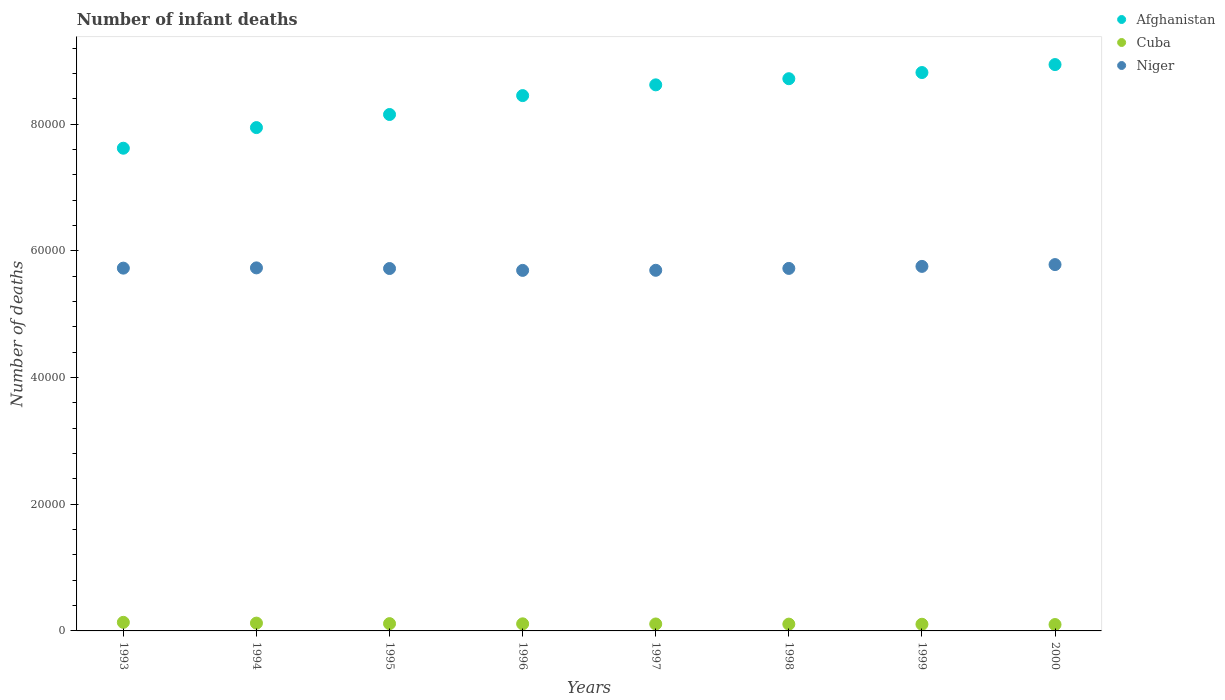Is the number of dotlines equal to the number of legend labels?
Keep it short and to the point. Yes. What is the number of infant deaths in Afghanistan in 1995?
Give a very brief answer. 8.15e+04. Across all years, what is the maximum number of infant deaths in Cuba?
Keep it short and to the point. 1355. Across all years, what is the minimum number of infant deaths in Niger?
Ensure brevity in your answer.  5.69e+04. In which year was the number of infant deaths in Afghanistan maximum?
Provide a short and direct response. 2000. In which year was the number of infant deaths in Niger minimum?
Your answer should be very brief. 1996. What is the total number of infant deaths in Cuba in the graph?
Keep it short and to the point. 9085. What is the difference between the number of infant deaths in Cuba in 1995 and the number of infant deaths in Afghanistan in 1999?
Provide a short and direct response. -8.70e+04. What is the average number of infant deaths in Afghanistan per year?
Make the answer very short. 8.41e+04. In the year 1993, what is the difference between the number of infant deaths in Niger and number of infant deaths in Afghanistan?
Give a very brief answer. -1.89e+04. What is the ratio of the number of infant deaths in Cuba in 1993 to that in 1999?
Keep it short and to the point. 1.29. Is the number of infant deaths in Niger in 1998 less than that in 1999?
Provide a succinct answer. Yes. Is the difference between the number of infant deaths in Niger in 1997 and 1998 greater than the difference between the number of infant deaths in Afghanistan in 1997 and 1998?
Offer a very short reply. Yes. What is the difference between the highest and the second highest number of infant deaths in Niger?
Offer a terse response. 284. What is the difference between the highest and the lowest number of infant deaths in Afghanistan?
Your answer should be compact. 1.32e+04. Is the sum of the number of infant deaths in Niger in 1996 and 2000 greater than the maximum number of infant deaths in Afghanistan across all years?
Make the answer very short. Yes. How many dotlines are there?
Your answer should be compact. 3. How many years are there in the graph?
Ensure brevity in your answer.  8. What is the difference between two consecutive major ticks on the Y-axis?
Offer a very short reply. 2.00e+04. Are the values on the major ticks of Y-axis written in scientific E-notation?
Provide a short and direct response. No. Does the graph contain grids?
Your answer should be very brief. No. Where does the legend appear in the graph?
Your answer should be very brief. Top right. How many legend labels are there?
Provide a succinct answer. 3. What is the title of the graph?
Offer a very short reply. Number of infant deaths. What is the label or title of the Y-axis?
Give a very brief answer. Number of deaths. What is the Number of deaths of Afghanistan in 1993?
Provide a succinct answer. 7.62e+04. What is the Number of deaths of Cuba in 1993?
Offer a very short reply. 1355. What is the Number of deaths in Niger in 1993?
Keep it short and to the point. 5.73e+04. What is the Number of deaths of Afghanistan in 1994?
Your answer should be compact. 7.94e+04. What is the Number of deaths of Cuba in 1994?
Ensure brevity in your answer.  1232. What is the Number of deaths in Niger in 1994?
Offer a very short reply. 5.73e+04. What is the Number of deaths in Afghanistan in 1995?
Give a very brief answer. 8.15e+04. What is the Number of deaths in Cuba in 1995?
Ensure brevity in your answer.  1150. What is the Number of deaths of Niger in 1995?
Provide a succinct answer. 5.72e+04. What is the Number of deaths of Afghanistan in 1996?
Provide a short and direct response. 8.45e+04. What is the Number of deaths of Cuba in 1996?
Your response must be concise. 1119. What is the Number of deaths of Niger in 1996?
Your answer should be very brief. 5.69e+04. What is the Number of deaths in Afghanistan in 1997?
Provide a short and direct response. 8.62e+04. What is the Number of deaths of Cuba in 1997?
Your response must be concise. 1097. What is the Number of deaths of Niger in 1997?
Provide a short and direct response. 5.69e+04. What is the Number of deaths in Afghanistan in 1998?
Provide a short and direct response. 8.72e+04. What is the Number of deaths of Cuba in 1998?
Offer a terse response. 1073. What is the Number of deaths in Niger in 1998?
Your answer should be very brief. 5.72e+04. What is the Number of deaths in Afghanistan in 1999?
Give a very brief answer. 8.81e+04. What is the Number of deaths of Cuba in 1999?
Your response must be concise. 1052. What is the Number of deaths of Niger in 1999?
Your response must be concise. 5.75e+04. What is the Number of deaths of Afghanistan in 2000?
Give a very brief answer. 8.94e+04. What is the Number of deaths of Cuba in 2000?
Provide a short and direct response. 1007. What is the Number of deaths of Niger in 2000?
Provide a short and direct response. 5.78e+04. Across all years, what is the maximum Number of deaths in Afghanistan?
Provide a short and direct response. 8.94e+04. Across all years, what is the maximum Number of deaths of Cuba?
Ensure brevity in your answer.  1355. Across all years, what is the maximum Number of deaths in Niger?
Your answer should be very brief. 5.78e+04. Across all years, what is the minimum Number of deaths in Afghanistan?
Provide a succinct answer. 7.62e+04. Across all years, what is the minimum Number of deaths in Cuba?
Offer a very short reply. 1007. Across all years, what is the minimum Number of deaths of Niger?
Your answer should be compact. 5.69e+04. What is the total Number of deaths of Afghanistan in the graph?
Give a very brief answer. 6.73e+05. What is the total Number of deaths of Cuba in the graph?
Offer a terse response. 9085. What is the total Number of deaths of Niger in the graph?
Offer a terse response. 4.58e+05. What is the difference between the Number of deaths in Afghanistan in 1993 and that in 1994?
Your answer should be very brief. -3256. What is the difference between the Number of deaths of Cuba in 1993 and that in 1994?
Provide a short and direct response. 123. What is the difference between the Number of deaths in Niger in 1993 and that in 1994?
Provide a succinct answer. -40. What is the difference between the Number of deaths of Afghanistan in 1993 and that in 1995?
Your response must be concise. -5323. What is the difference between the Number of deaths in Cuba in 1993 and that in 1995?
Ensure brevity in your answer.  205. What is the difference between the Number of deaths of Afghanistan in 1993 and that in 1996?
Your answer should be compact. -8305. What is the difference between the Number of deaths in Cuba in 1993 and that in 1996?
Your response must be concise. 236. What is the difference between the Number of deaths of Niger in 1993 and that in 1996?
Give a very brief answer. 355. What is the difference between the Number of deaths in Afghanistan in 1993 and that in 1997?
Offer a very short reply. -1.00e+04. What is the difference between the Number of deaths in Cuba in 1993 and that in 1997?
Give a very brief answer. 258. What is the difference between the Number of deaths in Niger in 1993 and that in 1997?
Give a very brief answer. 340. What is the difference between the Number of deaths of Afghanistan in 1993 and that in 1998?
Make the answer very short. -1.10e+04. What is the difference between the Number of deaths in Cuba in 1993 and that in 1998?
Provide a short and direct response. 282. What is the difference between the Number of deaths of Niger in 1993 and that in 1998?
Your answer should be very brief. 44. What is the difference between the Number of deaths in Afghanistan in 1993 and that in 1999?
Offer a very short reply. -1.19e+04. What is the difference between the Number of deaths of Cuba in 1993 and that in 1999?
Offer a very short reply. 303. What is the difference between the Number of deaths of Niger in 1993 and that in 1999?
Keep it short and to the point. -276. What is the difference between the Number of deaths in Afghanistan in 1993 and that in 2000?
Keep it short and to the point. -1.32e+04. What is the difference between the Number of deaths in Cuba in 1993 and that in 2000?
Keep it short and to the point. 348. What is the difference between the Number of deaths in Niger in 1993 and that in 2000?
Offer a very short reply. -560. What is the difference between the Number of deaths in Afghanistan in 1994 and that in 1995?
Give a very brief answer. -2067. What is the difference between the Number of deaths of Cuba in 1994 and that in 1995?
Your response must be concise. 82. What is the difference between the Number of deaths in Niger in 1994 and that in 1995?
Your answer should be compact. 101. What is the difference between the Number of deaths in Afghanistan in 1994 and that in 1996?
Your response must be concise. -5049. What is the difference between the Number of deaths in Cuba in 1994 and that in 1996?
Keep it short and to the point. 113. What is the difference between the Number of deaths in Niger in 1994 and that in 1996?
Ensure brevity in your answer.  395. What is the difference between the Number of deaths in Afghanistan in 1994 and that in 1997?
Provide a succinct answer. -6747. What is the difference between the Number of deaths of Cuba in 1994 and that in 1997?
Give a very brief answer. 135. What is the difference between the Number of deaths of Niger in 1994 and that in 1997?
Keep it short and to the point. 380. What is the difference between the Number of deaths in Afghanistan in 1994 and that in 1998?
Give a very brief answer. -7716. What is the difference between the Number of deaths of Cuba in 1994 and that in 1998?
Provide a succinct answer. 159. What is the difference between the Number of deaths of Afghanistan in 1994 and that in 1999?
Keep it short and to the point. -8690. What is the difference between the Number of deaths in Cuba in 1994 and that in 1999?
Provide a short and direct response. 180. What is the difference between the Number of deaths of Niger in 1994 and that in 1999?
Your answer should be compact. -236. What is the difference between the Number of deaths in Afghanistan in 1994 and that in 2000?
Your answer should be very brief. -9947. What is the difference between the Number of deaths in Cuba in 1994 and that in 2000?
Ensure brevity in your answer.  225. What is the difference between the Number of deaths of Niger in 1994 and that in 2000?
Offer a very short reply. -520. What is the difference between the Number of deaths in Afghanistan in 1995 and that in 1996?
Ensure brevity in your answer.  -2982. What is the difference between the Number of deaths in Cuba in 1995 and that in 1996?
Provide a succinct answer. 31. What is the difference between the Number of deaths of Niger in 1995 and that in 1996?
Provide a succinct answer. 294. What is the difference between the Number of deaths in Afghanistan in 1995 and that in 1997?
Your answer should be compact. -4680. What is the difference between the Number of deaths in Niger in 1995 and that in 1997?
Your response must be concise. 279. What is the difference between the Number of deaths in Afghanistan in 1995 and that in 1998?
Your response must be concise. -5649. What is the difference between the Number of deaths in Afghanistan in 1995 and that in 1999?
Provide a short and direct response. -6623. What is the difference between the Number of deaths in Cuba in 1995 and that in 1999?
Offer a terse response. 98. What is the difference between the Number of deaths of Niger in 1995 and that in 1999?
Make the answer very short. -337. What is the difference between the Number of deaths of Afghanistan in 1995 and that in 2000?
Offer a very short reply. -7880. What is the difference between the Number of deaths in Cuba in 1995 and that in 2000?
Offer a very short reply. 143. What is the difference between the Number of deaths of Niger in 1995 and that in 2000?
Offer a terse response. -621. What is the difference between the Number of deaths in Afghanistan in 1996 and that in 1997?
Give a very brief answer. -1698. What is the difference between the Number of deaths in Niger in 1996 and that in 1997?
Your response must be concise. -15. What is the difference between the Number of deaths of Afghanistan in 1996 and that in 1998?
Keep it short and to the point. -2667. What is the difference between the Number of deaths in Niger in 1996 and that in 1998?
Your answer should be compact. -311. What is the difference between the Number of deaths in Afghanistan in 1996 and that in 1999?
Provide a short and direct response. -3641. What is the difference between the Number of deaths of Niger in 1996 and that in 1999?
Make the answer very short. -631. What is the difference between the Number of deaths in Afghanistan in 1996 and that in 2000?
Ensure brevity in your answer.  -4898. What is the difference between the Number of deaths in Cuba in 1996 and that in 2000?
Make the answer very short. 112. What is the difference between the Number of deaths of Niger in 1996 and that in 2000?
Your answer should be very brief. -915. What is the difference between the Number of deaths of Afghanistan in 1997 and that in 1998?
Provide a short and direct response. -969. What is the difference between the Number of deaths in Niger in 1997 and that in 1998?
Provide a succinct answer. -296. What is the difference between the Number of deaths in Afghanistan in 1997 and that in 1999?
Keep it short and to the point. -1943. What is the difference between the Number of deaths of Cuba in 1997 and that in 1999?
Ensure brevity in your answer.  45. What is the difference between the Number of deaths in Niger in 1997 and that in 1999?
Provide a short and direct response. -616. What is the difference between the Number of deaths in Afghanistan in 1997 and that in 2000?
Your answer should be compact. -3200. What is the difference between the Number of deaths in Niger in 1997 and that in 2000?
Your response must be concise. -900. What is the difference between the Number of deaths of Afghanistan in 1998 and that in 1999?
Give a very brief answer. -974. What is the difference between the Number of deaths of Cuba in 1998 and that in 1999?
Make the answer very short. 21. What is the difference between the Number of deaths in Niger in 1998 and that in 1999?
Give a very brief answer. -320. What is the difference between the Number of deaths in Afghanistan in 1998 and that in 2000?
Your answer should be compact. -2231. What is the difference between the Number of deaths of Cuba in 1998 and that in 2000?
Your answer should be compact. 66. What is the difference between the Number of deaths in Niger in 1998 and that in 2000?
Keep it short and to the point. -604. What is the difference between the Number of deaths of Afghanistan in 1999 and that in 2000?
Provide a succinct answer. -1257. What is the difference between the Number of deaths in Cuba in 1999 and that in 2000?
Keep it short and to the point. 45. What is the difference between the Number of deaths in Niger in 1999 and that in 2000?
Make the answer very short. -284. What is the difference between the Number of deaths in Afghanistan in 1993 and the Number of deaths in Cuba in 1994?
Keep it short and to the point. 7.50e+04. What is the difference between the Number of deaths of Afghanistan in 1993 and the Number of deaths of Niger in 1994?
Your answer should be very brief. 1.89e+04. What is the difference between the Number of deaths of Cuba in 1993 and the Number of deaths of Niger in 1994?
Provide a short and direct response. -5.59e+04. What is the difference between the Number of deaths in Afghanistan in 1993 and the Number of deaths in Cuba in 1995?
Offer a terse response. 7.50e+04. What is the difference between the Number of deaths in Afghanistan in 1993 and the Number of deaths in Niger in 1995?
Offer a very short reply. 1.90e+04. What is the difference between the Number of deaths of Cuba in 1993 and the Number of deaths of Niger in 1995?
Your response must be concise. -5.58e+04. What is the difference between the Number of deaths in Afghanistan in 1993 and the Number of deaths in Cuba in 1996?
Your response must be concise. 7.51e+04. What is the difference between the Number of deaths in Afghanistan in 1993 and the Number of deaths in Niger in 1996?
Offer a very short reply. 1.93e+04. What is the difference between the Number of deaths of Cuba in 1993 and the Number of deaths of Niger in 1996?
Offer a terse response. -5.56e+04. What is the difference between the Number of deaths in Afghanistan in 1993 and the Number of deaths in Cuba in 1997?
Offer a terse response. 7.51e+04. What is the difference between the Number of deaths of Afghanistan in 1993 and the Number of deaths of Niger in 1997?
Your answer should be compact. 1.93e+04. What is the difference between the Number of deaths in Cuba in 1993 and the Number of deaths in Niger in 1997?
Offer a very short reply. -5.56e+04. What is the difference between the Number of deaths in Afghanistan in 1993 and the Number of deaths in Cuba in 1998?
Provide a succinct answer. 7.51e+04. What is the difference between the Number of deaths in Afghanistan in 1993 and the Number of deaths in Niger in 1998?
Keep it short and to the point. 1.90e+04. What is the difference between the Number of deaths in Cuba in 1993 and the Number of deaths in Niger in 1998?
Offer a very short reply. -5.59e+04. What is the difference between the Number of deaths of Afghanistan in 1993 and the Number of deaths of Cuba in 1999?
Give a very brief answer. 7.51e+04. What is the difference between the Number of deaths in Afghanistan in 1993 and the Number of deaths in Niger in 1999?
Your answer should be compact. 1.87e+04. What is the difference between the Number of deaths of Cuba in 1993 and the Number of deaths of Niger in 1999?
Offer a terse response. -5.62e+04. What is the difference between the Number of deaths of Afghanistan in 1993 and the Number of deaths of Cuba in 2000?
Offer a terse response. 7.52e+04. What is the difference between the Number of deaths of Afghanistan in 1993 and the Number of deaths of Niger in 2000?
Your response must be concise. 1.84e+04. What is the difference between the Number of deaths in Cuba in 1993 and the Number of deaths in Niger in 2000?
Make the answer very short. -5.65e+04. What is the difference between the Number of deaths in Afghanistan in 1994 and the Number of deaths in Cuba in 1995?
Provide a short and direct response. 7.83e+04. What is the difference between the Number of deaths of Afghanistan in 1994 and the Number of deaths of Niger in 1995?
Make the answer very short. 2.22e+04. What is the difference between the Number of deaths of Cuba in 1994 and the Number of deaths of Niger in 1995?
Make the answer very short. -5.60e+04. What is the difference between the Number of deaths in Afghanistan in 1994 and the Number of deaths in Cuba in 1996?
Keep it short and to the point. 7.83e+04. What is the difference between the Number of deaths in Afghanistan in 1994 and the Number of deaths in Niger in 1996?
Provide a succinct answer. 2.25e+04. What is the difference between the Number of deaths of Cuba in 1994 and the Number of deaths of Niger in 1996?
Ensure brevity in your answer.  -5.57e+04. What is the difference between the Number of deaths in Afghanistan in 1994 and the Number of deaths in Cuba in 1997?
Your answer should be very brief. 7.83e+04. What is the difference between the Number of deaths of Afghanistan in 1994 and the Number of deaths of Niger in 1997?
Provide a short and direct response. 2.25e+04. What is the difference between the Number of deaths in Cuba in 1994 and the Number of deaths in Niger in 1997?
Offer a very short reply. -5.57e+04. What is the difference between the Number of deaths in Afghanistan in 1994 and the Number of deaths in Cuba in 1998?
Make the answer very short. 7.84e+04. What is the difference between the Number of deaths in Afghanistan in 1994 and the Number of deaths in Niger in 1998?
Your answer should be compact. 2.22e+04. What is the difference between the Number of deaths of Cuba in 1994 and the Number of deaths of Niger in 1998?
Your answer should be very brief. -5.60e+04. What is the difference between the Number of deaths in Afghanistan in 1994 and the Number of deaths in Cuba in 1999?
Provide a short and direct response. 7.84e+04. What is the difference between the Number of deaths of Afghanistan in 1994 and the Number of deaths of Niger in 1999?
Your answer should be very brief. 2.19e+04. What is the difference between the Number of deaths of Cuba in 1994 and the Number of deaths of Niger in 1999?
Provide a succinct answer. -5.63e+04. What is the difference between the Number of deaths in Afghanistan in 1994 and the Number of deaths in Cuba in 2000?
Make the answer very short. 7.84e+04. What is the difference between the Number of deaths in Afghanistan in 1994 and the Number of deaths in Niger in 2000?
Provide a short and direct response. 2.16e+04. What is the difference between the Number of deaths of Cuba in 1994 and the Number of deaths of Niger in 2000?
Your answer should be compact. -5.66e+04. What is the difference between the Number of deaths in Afghanistan in 1995 and the Number of deaths in Cuba in 1996?
Ensure brevity in your answer.  8.04e+04. What is the difference between the Number of deaths in Afghanistan in 1995 and the Number of deaths in Niger in 1996?
Provide a short and direct response. 2.46e+04. What is the difference between the Number of deaths in Cuba in 1995 and the Number of deaths in Niger in 1996?
Provide a succinct answer. -5.58e+04. What is the difference between the Number of deaths in Afghanistan in 1995 and the Number of deaths in Cuba in 1997?
Provide a short and direct response. 8.04e+04. What is the difference between the Number of deaths of Afghanistan in 1995 and the Number of deaths of Niger in 1997?
Provide a short and direct response. 2.46e+04. What is the difference between the Number of deaths in Cuba in 1995 and the Number of deaths in Niger in 1997?
Make the answer very short. -5.58e+04. What is the difference between the Number of deaths in Afghanistan in 1995 and the Number of deaths in Cuba in 1998?
Your response must be concise. 8.04e+04. What is the difference between the Number of deaths in Afghanistan in 1995 and the Number of deaths in Niger in 1998?
Your answer should be very brief. 2.43e+04. What is the difference between the Number of deaths in Cuba in 1995 and the Number of deaths in Niger in 1998?
Provide a short and direct response. -5.61e+04. What is the difference between the Number of deaths in Afghanistan in 1995 and the Number of deaths in Cuba in 1999?
Provide a short and direct response. 8.05e+04. What is the difference between the Number of deaths of Afghanistan in 1995 and the Number of deaths of Niger in 1999?
Your answer should be compact. 2.40e+04. What is the difference between the Number of deaths of Cuba in 1995 and the Number of deaths of Niger in 1999?
Provide a succinct answer. -5.64e+04. What is the difference between the Number of deaths of Afghanistan in 1995 and the Number of deaths of Cuba in 2000?
Your answer should be very brief. 8.05e+04. What is the difference between the Number of deaths of Afghanistan in 1995 and the Number of deaths of Niger in 2000?
Offer a terse response. 2.37e+04. What is the difference between the Number of deaths of Cuba in 1995 and the Number of deaths of Niger in 2000?
Provide a succinct answer. -5.67e+04. What is the difference between the Number of deaths of Afghanistan in 1996 and the Number of deaths of Cuba in 1997?
Offer a terse response. 8.34e+04. What is the difference between the Number of deaths in Afghanistan in 1996 and the Number of deaths in Niger in 1997?
Offer a very short reply. 2.76e+04. What is the difference between the Number of deaths in Cuba in 1996 and the Number of deaths in Niger in 1997?
Your answer should be very brief. -5.58e+04. What is the difference between the Number of deaths of Afghanistan in 1996 and the Number of deaths of Cuba in 1998?
Keep it short and to the point. 8.34e+04. What is the difference between the Number of deaths of Afghanistan in 1996 and the Number of deaths of Niger in 1998?
Offer a terse response. 2.73e+04. What is the difference between the Number of deaths of Cuba in 1996 and the Number of deaths of Niger in 1998?
Give a very brief answer. -5.61e+04. What is the difference between the Number of deaths of Afghanistan in 1996 and the Number of deaths of Cuba in 1999?
Make the answer very short. 8.34e+04. What is the difference between the Number of deaths in Afghanistan in 1996 and the Number of deaths in Niger in 1999?
Make the answer very short. 2.70e+04. What is the difference between the Number of deaths in Cuba in 1996 and the Number of deaths in Niger in 1999?
Give a very brief answer. -5.64e+04. What is the difference between the Number of deaths in Afghanistan in 1996 and the Number of deaths in Cuba in 2000?
Offer a terse response. 8.35e+04. What is the difference between the Number of deaths in Afghanistan in 1996 and the Number of deaths in Niger in 2000?
Ensure brevity in your answer.  2.67e+04. What is the difference between the Number of deaths of Cuba in 1996 and the Number of deaths of Niger in 2000?
Your answer should be compact. -5.67e+04. What is the difference between the Number of deaths in Afghanistan in 1997 and the Number of deaths in Cuba in 1998?
Offer a terse response. 8.51e+04. What is the difference between the Number of deaths in Afghanistan in 1997 and the Number of deaths in Niger in 1998?
Ensure brevity in your answer.  2.90e+04. What is the difference between the Number of deaths of Cuba in 1997 and the Number of deaths of Niger in 1998?
Make the answer very short. -5.61e+04. What is the difference between the Number of deaths in Afghanistan in 1997 and the Number of deaths in Cuba in 1999?
Offer a very short reply. 8.51e+04. What is the difference between the Number of deaths of Afghanistan in 1997 and the Number of deaths of Niger in 1999?
Provide a succinct answer. 2.87e+04. What is the difference between the Number of deaths of Cuba in 1997 and the Number of deaths of Niger in 1999?
Your response must be concise. -5.64e+04. What is the difference between the Number of deaths of Afghanistan in 1997 and the Number of deaths of Cuba in 2000?
Give a very brief answer. 8.52e+04. What is the difference between the Number of deaths of Afghanistan in 1997 and the Number of deaths of Niger in 2000?
Your response must be concise. 2.84e+04. What is the difference between the Number of deaths in Cuba in 1997 and the Number of deaths in Niger in 2000?
Give a very brief answer. -5.67e+04. What is the difference between the Number of deaths of Afghanistan in 1998 and the Number of deaths of Cuba in 1999?
Ensure brevity in your answer.  8.61e+04. What is the difference between the Number of deaths of Afghanistan in 1998 and the Number of deaths of Niger in 1999?
Provide a succinct answer. 2.96e+04. What is the difference between the Number of deaths in Cuba in 1998 and the Number of deaths in Niger in 1999?
Ensure brevity in your answer.  -5.65e+04. What is the difference between the Number of deaths in Afghanistan in 1998 and the Number of deaths in Cuba in 2000?
Your response must be concise. 8.62e+04. What is the difference between the Number of deaths in Afghanistan in 1998 and the Number of deaths in Niger in 2000?
Offer a very short reply. 2.93e+04. What is the difference between the Number of deaths in Cuba in 1998 and the Number of deaths in Niger in 2000?
Provide a short and direct response. -5.67e+04. What is the difference between the Number of deaths of Afghanistan in 1999 and the Number of deaths of Cuba in 2000?
Provide a short and direct response. 8.71e+04. What is the difference between the Number of deaths of Afghanistan in 1999 and the Number of deaths of Niger in 2000?
Your response must be concise. 3.03e+04. What is the difference between the Number of deaths of Cuba in 1999 and the Number of deaths of Niger in 2000?
Ensure brevity in your answer.  -5.68e+04. What is the average Number of deaths in Afghanistan per year?
Give a very brief answer. 8.41e+04. What is the average Number of deaths in Cuba per year?
Provide a succinct answer. 1135.62. What is the average Number of deaths of Niger per year?
Offer a terse response. 5.73e+04. In the year 1993, what is the difference between the Number of deaths in Afghanistan and Number of deaths in Cuba?
Your response must be concise. 7.48e+04. In the year 1993, what is the difference between the Number of deaths of Afghanistan and Number of deaths of Niger?
Offer a very short reply. 1.89e+04. In the year 1993, what is the difference between the Number of deaths of Cuba and Number of deaths of Niger?
Offer a terse response. -5.59e+04. In the year 1994, what is the difference between the Number of deaths in Afghanistan and Number of deaths in Cuba?
Make the answer very short. 7.82e+04. In the year 1994, what is the difference between the Number of deaths of Afghanistan and Number of deaths of Niger?
Ensure brevity in your answer.  2.21e+04. In the year 1994, what is the difference between the Number of deaths of Cuba and Number of deaths of Niger?
Ensure brevity in your answer.  -5.61e+04. In the year 1995, what is the difference between the Number of deaths in Afghanistan and Number of deaths in Cuba?
Your answer should be compact. 8.04e+04. In the year 1995, what is the difference between the Number of deaths in Afghanistan and Number of deaths in Niger?
Make the answer very short. 2.43e+04. In the year 1995, what is the difference between the Number of deaths of Cuba and Number of deaths of Niger?
Keep it short and to the point. -5.61e+04. In the year 1996, what is the difference between the Number of deaths in Afghanistan and Number of deaths in Cuba?
Your answer should be very brief. 8.34e+04. In the year 1996, what is the difference between the Number of deaths in Afghanistan and Number of deaths in Niger?
Keep it short and to the point. 2.76e+04. In the year 1996, what is the difference between the Number of deaths in Cuba and Number of deaths in Niger?
Ensure brevity in your answer.  -5.58e+04. In the year 1997, what is the difference between the Number of deaths in Afghanistan and Number of deaths in Cuba?
Ensure brevity in your answer.  8.51e+04. In the year 1997, what is the difference between the Number of deaths of Afghanistan and Number of deaths of Niger?
Your response must be concise. 2.93e+04. In the year 1997, what is the difference between the Number of deaths in Cuba and Number of deaths in Niger?
Ensure brevity in your answer.  -5.58e+04. In the year 1998, what is the difference between the Number of deaths of Afghanistan and Number of deaths of Cuba?
Ensure brevity in your answer.  8.61e+04. In the year 1998, what is the difference between the Number of deaths in Afghanistan and Number of deaths in Niger?
Give a very brief answer. 2.99e+04. In the year 1998, what is the difference between the Number of deaths in Cuba and Number of deaths in Niger?
Provide a succinct answer. -5.61e+04. In the year 1999, what is the difference between the Number of deaths of Afghanistan and Number of deaths of Cuba?
Your answer should be very brief. 8.71e+04. In the year 1999, what is the difference between the Number of deaths of Afghanistan and Number of deaths of Niger?
Your answer should be compact. 3.06e+04. In the year 1999, what is the difference between the Number of deaths in Cuba and Number of deaths in Niger?
Your response must be concise. -5.65e+04. In the year 2000, what is the difference between the Number of deaths of Afghanistan and Number of deaths of Cuba?
Give a very brief answer. 8.84e+04. In the year 2000, what is the difference between the Number of deaths of Afghanistan and Number of deaths of Niger?
Offer a terse response. 3.16e+04. In the year 2000, what is the difference between the Number of deaths in Cuba and Number of deaths in Niger?
Ensure brevity in your answer.  -5.68e+04. What is the ratio of the Number of deaths of Afghanistan in 1993 to that in 1994?
Provide a short and direct response. 0.96. What is the ratio of the Number of deaths of Cuba in 1993 to that in 1994?
Offer a very short reply. 1.1. What is the ratio of the Number of deaths in Niger in 1993 to that in 1994?
Provide a short and direct response. 1. What is the ratio of the Number of deaths of Afghanistan in 1993 to that in 1995?
Provide a short and direct response. 0.93. What is the ratio of the Number of deaths of Cuba in 1993 to that in 1995?
Make the answer very short. 1.18. What is the ratio of the Number of deaths in Niger in 1993 to that in 1995?
Offer a very short reply. 1. What is the ratio of the Number of deaths in Afghanistan in 1993 to that in 1996?
Keep it short and to the point. 0.9. What is the ratio of the Number of deaths of Cuba in 1993 to that in 1996?
Offer a terse response. 1.21. What is the ratio of the Number of deaths of Afghanistan in 1993 to that in 1997?
Provide a succinct answer. 0.88. What is the ratio of the Number of deaths in Cuba in 1993 to that in 1997?
Make the answer very short. 1.24. What is the ratio of the Number of deaths in Niger in 1993 to that in 1997?
Keep it short and to the point. 1.01. What is the ratio of the Number of deaths in Afghanistan in 1993 to that in 1998?
Offer a very short reply. 0.87. What is the ratio of the Number of deaths of Cuba in 1993 to that in 1998?
Ensure brevity in your answer.  1.26. What is the ratio of the Number of deaths in Niger in 1993 to that in 1998?
Your answer should be very brief. 1. What is the ratio of the Number of deaths in Afghanistan in 1993 to that in 1999?
Your response must be concise. 0.86. What is the ratio of the Number of deaths in Cuba in 1993 to that in 1999?
Provide a short and direct response. 1.29. What is the ratio of the Number of deaths of Niger in 1993 to that in 1999?
Give a very brief answer. 1. What is the ratio of the Number of deaths of Afghanistan in 1993 to that in 2000?
Give a very brief answer. 0.85. What is the ratio of the Number of deaths in Cuba in 1993 to that in 2000?
Make the answer very short. 1.35. What is the ratio of the Number of deaths of Niger in 1993 to that in 2000?
Offer a terse response. 0.99. What is the ratio of the Number of deaths of Afghanistan in 1994 to that in 1995?
Make the answer very short. 0.97. What is the ratio of the Number of deaths in Cuba in 1994 to that in 1995?
Ensure brevity in your answer.  1.07. What is the ratio of the Number of deaths in Niger in 1994 to that in 1995?
Your answer should be very brief. 1. What is the ratio of the Number of deaths in Afghanistan in 1994 to that in 1996?
Offer a terse response. 0.94. What is the ratio of the Number of deaths of Cuba in 1994 to that in 1996?
Provide a short and direct response. 1.1. What is the ratio of the Number of deaths of Afghanistan in 1994 to that in 1997?
Ensure brevity in your answer.  0.92. What is the ratio of the Number of deaths of Cuba in 1994 to that in 1997?
Your answer should be compact. 1.12. What is the ratio of the Number of deaths in Afghanistan in 1994 to that in 1998?
Give a very brief answer. 0.91. What is the ratio of the Number of deaths in Cuba in 1994 to that in 1998?
Your answer should be compact. 1.15. What is the ratio of the Number of deaths in Niger in 1994 to that in 1998?
Provide a succinct answer. 1. What is the ratio of the Number of deaths in Afghanistan in 1994 to that in 1999?
Provide a succinct answer. 0.9. What is the ratio of the Number of deaths of Cuba in 1994 to that in 1999?
Keep it short and to the point. 1.17. What is the ratio of the Number of deaths in Niger in 1994 to that in 1999?
Offer a very short reply. 1. What is the ratio of the Number of deaths of Afghanistan in 1994 to that in 2000?
Make the answer very short. 0.89. What is the ratio of the Number of deaths in Cuba in 1994 to that in 2000?
Your response must be concise. 1.22. What is the ratio of the Number of deaths of Afghanistan in 1995 to that in 1996?
Make the answer very short. 0.96. What is the ratio of the Number of deaths in Cuba in 1995 to that in 1996?
Your answer should be very brief. 1.03. What is the ratio of the Number of deaths of Niger in 1995 to that in 1996?
Ensure brevity in your answer.  1.01. What is the ratio of the Number of deaths in Afghanistan in 1995 to that in 1997?
Keep it short and to the point. 0.95. What is the ratio of the Number of deaths of Cuba in 1995 to that in 1997?
Your answer should be very brief. 1.05. What is the ratio of the Number of deaths of Niger in 1995 to that in 1997?
Ensure brevity in your answer.  1. What is the ratio of the Number of deaths in Afghanistan in 1995 to that in 1998?
Offer a very short reply. 0.94. What is the ratio of the Number of deaths in Cuba in 1995 to that in 1998?
Offer a terse response. 1.07. What is the ratio of the Number of deaths of Niger in 1995 to that in 1998?
Offer a very short reply. 1. What is the ratio of the Number of deaths in Afghanistan in 1995 to that in 1999?
Make the answer very short. 0.92. What is the ratio of the Number of deaths in Cuba in 1995 to that in 1999?
Ensure brevity in your answer.  1.09. What is the ratio of the Number of deaths of Afghanistan in 1995 to that in 2000?
Keep it short and to the point. 0.91. What is the ratio of the Number of deaths in Cuba in 1995 to that in 2000?
Offer a terse response. 1.14. What is the ratio of the Number of deaths of Niger in 1995 to that in 2000?
Give a very brief answer. 0.99. What is the ratio of the Number of deaths of Afghanistan in 1996 to that in 1997?
Your answer should be compact. 0.98. What is the ratio of the Number of deaths of Cuba in 1996 to that in 1997?
Make the answer very short. 1.02. What is the ratio of the Number of deaths in Niger in 1996 to that in 1997?
Provide a short and direct response. 1. What is the ratio of the Number of deaths in Afghanistan in 1996 to that in 1998?
Your answer should be compact. 0.97. What is the ratio of the Number of deaths of Cuba in 1996 to that in 1998?
Your response must be concise. 1.04. What is the ratio of the Number of deaths of Afghanistan in 1996 to that in 1999?
Make the answer very short. 0.96. What is the ratio of the Number of deaths in Cuba in 1996 to that in 1999?
Provide a short and direct response. 1.06. What is the ratio of the Number of deaths of Afghanistan in 1996 to that in 2000?
Your response must be concise. 0.95. What is the ratio of the Number of deaths in Cuba in 1996 to that in 2000?
Your answer should be compact. 1.11. What is the ratio of the Number of deaths in Niger in 1996 to that in 2000?
Offer a terse response. 0.98. What is the ratio of the Number of deaths of Afghanistan in 1997 to that in 1998?
Offer a very short reply. 0.99. What is the ratio of the Number of deaths of Cuba in 1997 to that in 1998?
Your answer should be compact. 1.02. What is the ratio of the Number of deaths in Cuba in 1997 to that in 1999?
Provide a short and direct response. 1.04. What is the ratio of the Number of deaths in Niger in 1997 to that in 1999?
Keep it short and to the point. 0.99. What is the ratio of the Number of deaths in Afghanistan in 1997 to that in 2000?
Keep it short and to the point. 0.96. What is the ratio of the Number of deaths of Cuba in 1997 to that in 2000?
Give a very brief answer. 1.09. What is the ratio of the Number of deaths in Niger in 1997 to that in 2000?
Keep it short and to the point. 0.98. What is the ratio of the Number of deaths in Afghanistan in 1998 to that in 1999?
Provide a short and direct response. 0.99. What is the ratio of the Number of deaths of Cuba in 1998 to that in 1999?
Give a very brief answer. 1.02. What is the ratio of the Number of deaths of Niger in 1998 to that in 1999?
Offer a very short reply. 0.99. What is the ratio of the Number of deaths in Afghanistan in 1998 to that in 2000?
Give a very brief answer. 0.97. What is the ratio of the Number of deaths in Cuba in 1998 to that in 2000?
Ensure brevity in your answer.  1.07. What is the ratio of the Number of deaths in Afghanistan in 1999 to that in 2000?
Keep it short and to the point. 0.99. What is the ratio of the Number of deaths in Cuba in 1999 to that in 2000?
Provide a short and direct response. 1.04. What is the difference between the highest and the second highest Number of deaths of Afghanistan?
Offer a terse response. 1257. What is the difference between the highest and the second highest Number of deaths in Cuba?
Make the answer very short. 123. What is the difference between the highest and the second highest Number of deaths in Niger?
Give a very brief answer. 284. What is the difference between the highest and the lowest Number of deaths in Afghanistan?
Give a very brief answer. 1.32e+04. What is the difference between the highest and the lowest Number of deaths of Cuba?
Make the answer very short. 348. What is the difference between the highest and the lowest Number of deaths in Niger?
Offer a terse response. 915. 